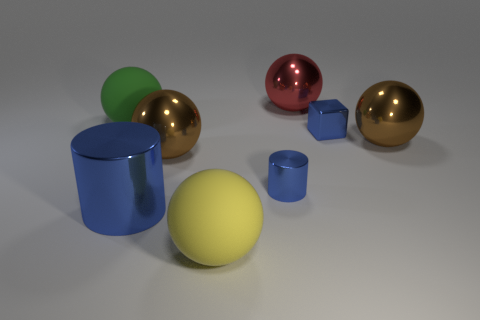Subtract all big brown metallic spheres. How many spheres are left? 3 Subtract 3 spheres. How many spheres are left? 2 Subtract all brown balls. How many balls are left? 3 Subtract all gray spheres. Subtract all purple cylinders. How many spheres are left? 5 Add 2 red metal objects. How many objects exist? 10 Subtract all cylinders. How many objects are left? 6 Add 4 tiny objects. How many tiny objects are left? 6 Add 5 red things. How many red things exist? 6 Subtract 0 gray blocks. How many objects are left? 8 Subtract all small metal cylinders. Subtract all tiny blue metallic blocks. How many objects are left? 6 